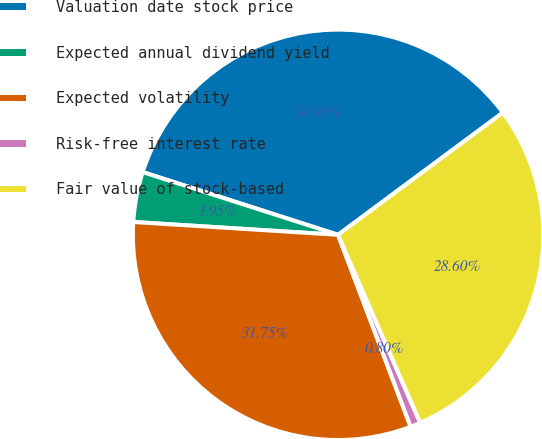Convert chart. <chart><loc_0><loc_0><loc_500><loc_500><pie_chart><fcel>Valuation date stock price<fcel>Expected annual dividend yield<fcel>Expected volatility<fcel>Risk-free interest rate<fcel>Fair value of stock-based<nl><fcel>34.9%<fcel>3.95%<fcel>31.75%<fcel>0.8%<fcel>28.6%<nl></chart> 